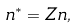Convert formula to latex. <formula><loc_0><loc_0><loc_500><loc_500>n ^ { \ast } = Z n ,</formula> 